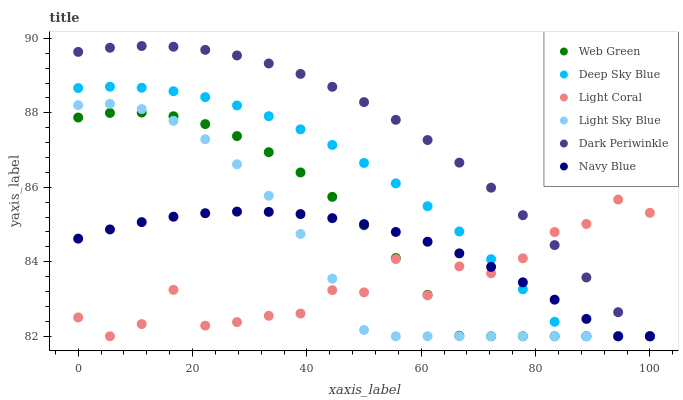Does Light Coral have the minimum area under the curve?
Answer yes or no. Yes. Does Dark Periwinkle have the maximum area under the curve?
Answer yes or no. Yes. Does Web Green have the minimum area under the curve?
Answer yes or no. No. Does Web Green have the maximum area under the curve?
Answer yes or no. No. Is Navy Blue the smoothest?
Answer yes or no. Yes. Is Light Coral the roughest?
Answer yes or no. Yes. Is Web Green the smoothest?
Answer yes or no. No. Is Web Green the roughest?
Answer yes or no. No. Does Navy Blue have the lowest value?
Answer yes or no. Yes. Does Dark Periwinkle have the highest value?
Answer yes or no. Yes. Does Web Green have the highest value?
Answer yes or no. No. Does Deep Sky Blue intersect Dark Periwinkle?
Answer yes or no. Yes. Is Deep Sky Blue less than Dark Periwinkle?
Answer yes or no. No. Is Deep Sky Blue greater than Dark Periwinkle?
Answer yes or no. No. 